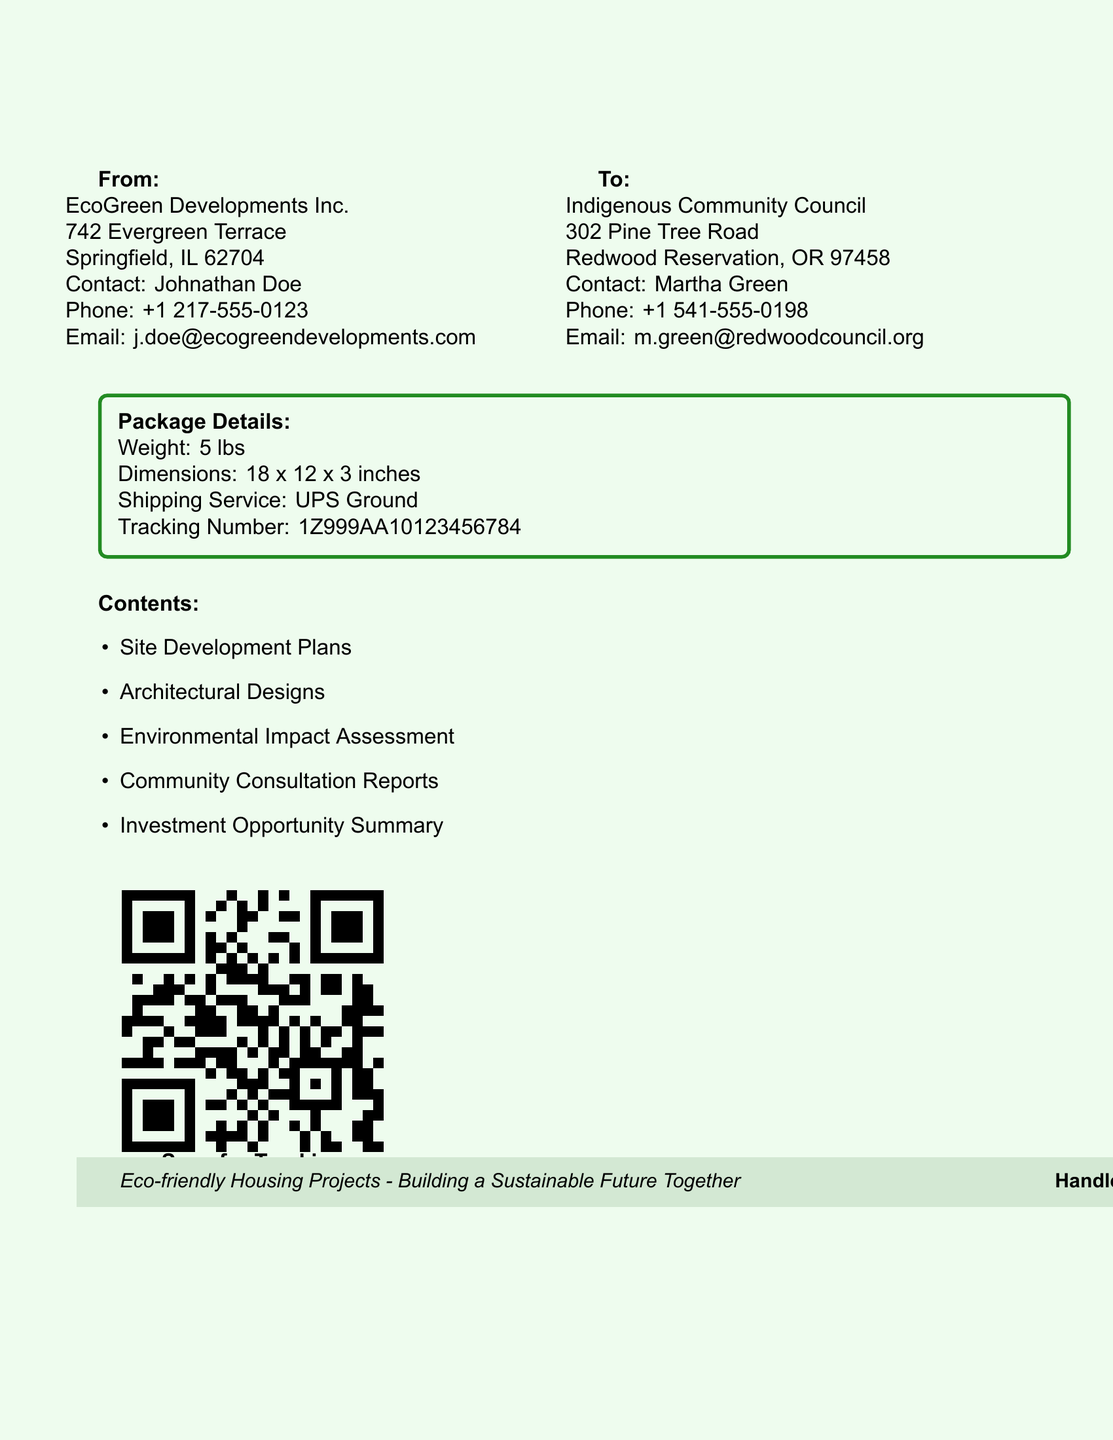What is the name of the sender? The sender's name is listed on the label under "From," which is EcoGreen Developments Inc.
Answer: EcoGreen Developments Inc What is the contact person's name for the recipient? The contact person's name is mentioned under "To," which is Martha Green.
Answer: Martha Green What is the weight of the package? The weight is specified under "Package Details" in the document as 5 lbs.
Answer: 5 lbs What is the shipping service used? The shipping service is detailed in the "Package Details" section, which states UPS Ground.
Answer: UPS Ground What is the tracking number? The tracking number is provided in the "Package Details," which is 1Z999AA10123456784.
Answer: 1Z999AA10123456784 What is one of the contents listed in the package? The contents section lists multiple items, including Site Development Plans.
Answer: Site Development Plans How many inches are the package dimensions? The dimensions are given in "Package Details" as 18 x 12 x 3 inches.
Answer: 18 x 12 x 3 inches Which city is EcoGreen Developments Inc. located in? The city of EcoGreen Developments Inc. is specified under "From" as Springfield.
Answer: Springfield What type of projects are identified in the footer? The footer section describes the projects targeted by EcoGreen Developments as eco-friendly housing projects.
Answer: Eco-friendly housing projects 